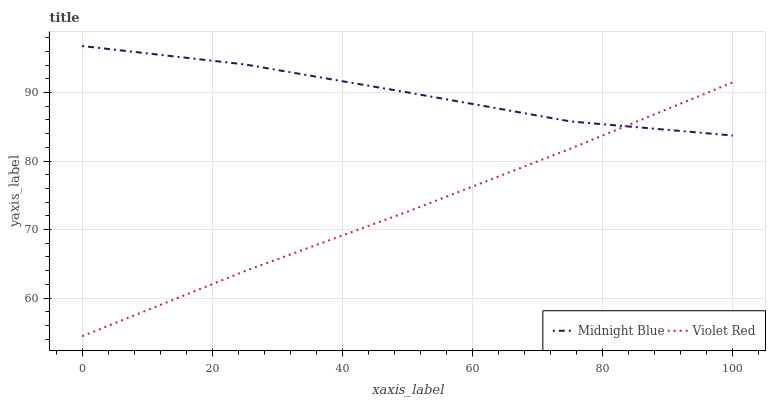Does Violet Red have the minimum area under the curve?
Answer yes or no. Yes. Does Midnight Blue have the maximum area under the curve?
Answer yes or no. Yes. Does Midnight Blue have the minimum area under the curve?
Answer yes or no. No. Is Violet Red the smoothest?
Answer yes or no. Yes. Is Midnight Blue the roughest?
Answer yes or no. Yes. Is Midnight Blue the smoothest?
Answer yes or no. No. Does Violet Red have the lowest value?
Answer yes or no. Yes. Does Midnight Blue have the lowest value?
Answer yes or no. No. Does Midnight Blue have the highest value?
Answer yes or no. Yes. Does Violet Red intersect Midnight Blue?
Answer yes or no. Yes. Is Violet Red less than Midnight Blue?
Answer yes or no. No. Is Violet Red greater than Midnight Blue?
Answer yes or no. No. 